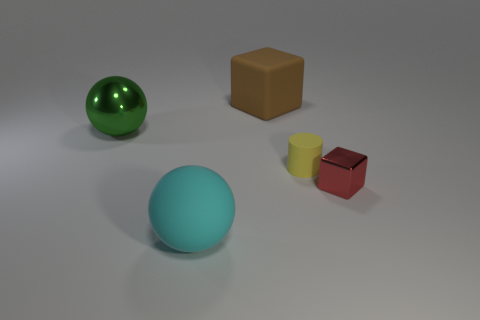There is a yellow cylinder that is the same material as the brown thing; what size is it?
Provide a succinct answer. Small. What material is the big object on the right side of the large sphere that is to the right of the large sphere behind the small shiny object?
Your response must be concise. Rubber. Are there more tiny red cubes that are right of the yellow matte cylinder than large rubber blocks behind the brown object?
Give a very brief answer. Yes. How many tiny yellow cylinders have the same material as the big green thing?
Your answer should be compact. 0. There is a rubber thing behind the yellow rubber thing; is its shape the same as the small red object to the right of the metal ball?
Your answer should be compact. Yes. What is the color of the large thing that is behind the green ball?
Your response must be concise. Brown. Is there another small thing that has the same shape as the brown object?
Give a very brief answer. Yes. What is the material of the cylinder?
Offer a terse response. Rubber. There is a thing that is behind the cylinder and on the right side of the cyan object; what is its size?
Provide a short and direct response. Large. What number of small red shiny blocks are there?
Offer a terse response. 1. 